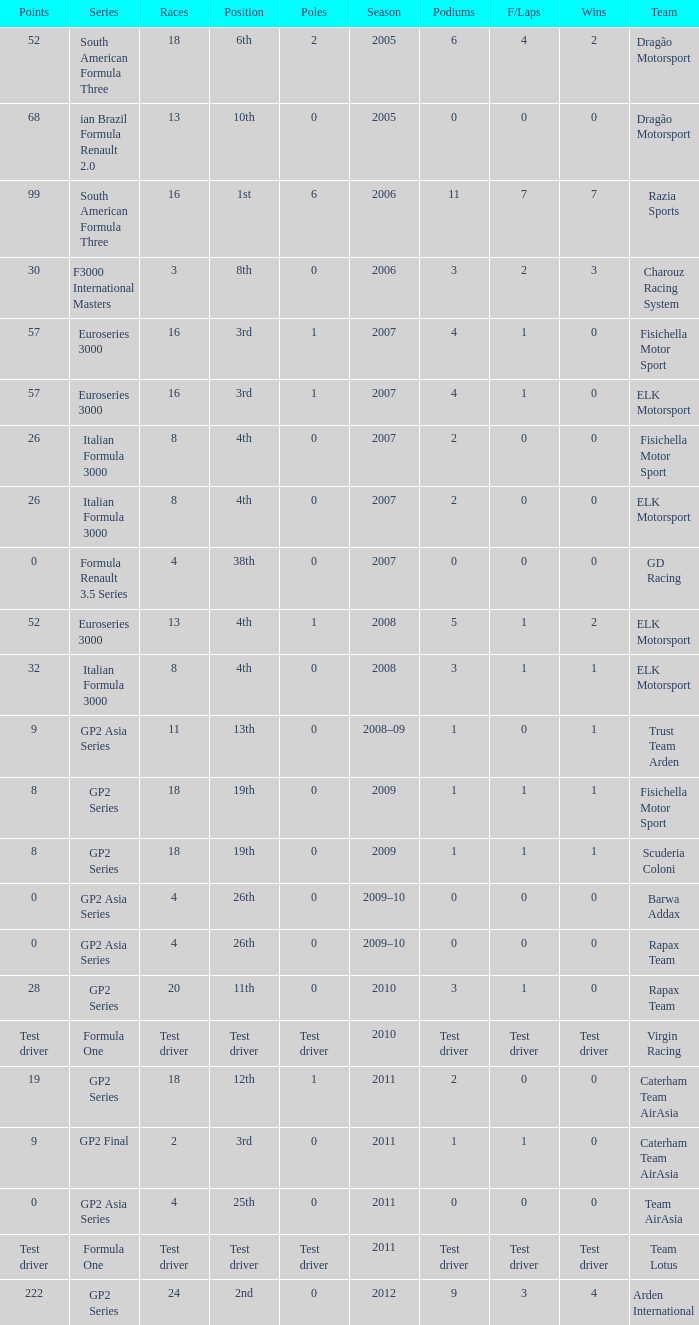In which season did he have 0 Poles and 19th position in the GP2 Series? 2009, 2009. 